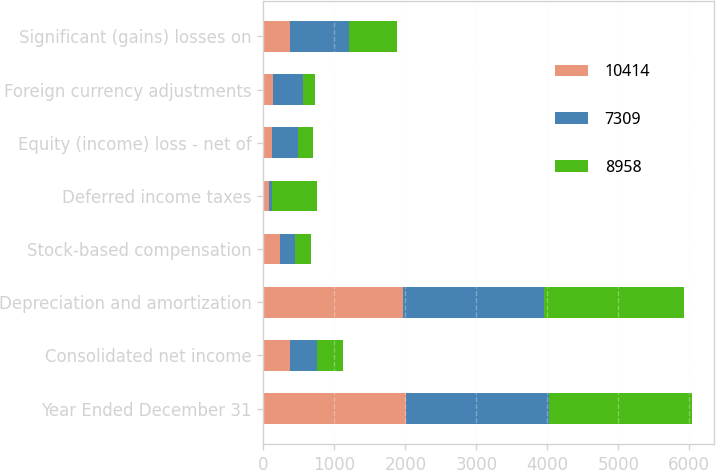Convert chart to OTSL. <chart><loc_0><loc_0><loc_500><loc_500><stacked_bar_chart><ecel><fcel>Year Ended December 31<fcel>Consolidated net income<fcel>Depreciation and amortization<fcel>Stock-based compensation<fcel>Deferred income taxes<fcel>Equity (income) loss - net of<fcel>Foreign currency adjustments<fcel>Significant (gains) losses on<nl><fcel>10414<fcel>2015<fcel>374<fcel>1970<fcel>236<fcel>73<fcel>122<fcel>137<fcel>374<nl><fcel>7309<fcel>2014<fcel>374<fcel>1976<fcel>209<fcel>40<fcel>371<fcel>415<fcel>831<nl><fcel>8958<fcel>2013<fcel>374<fcel>1977<fcel>227<fcel>648<fcel>201<fcel>168<fcel>670<nl></chart> 